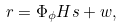<formula> <loc_0><loc_0><loc_500><loc_500>r = \Phi _ { \phi } H s + w ,</formula> 